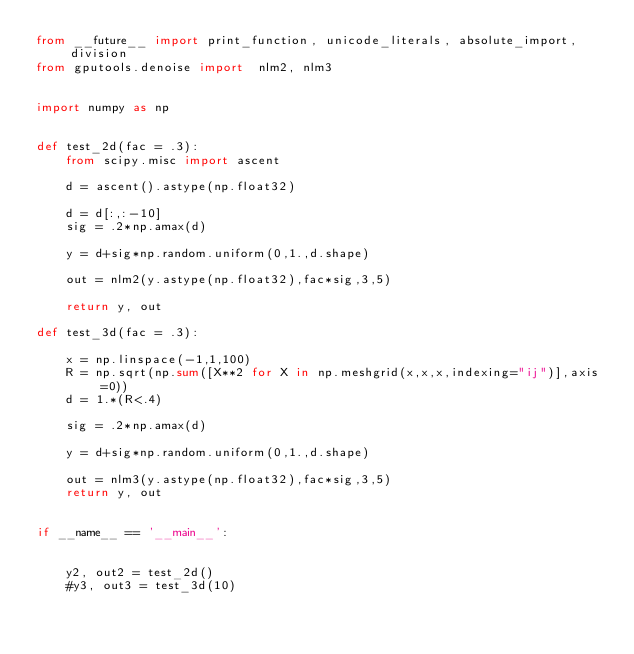<code> <loc_0><loc_0><loc_500><loc_500><_Python_>from __future__ import print_function, unicode_literals, absolute_import, division
from gputools.denoise import  nlm2, nlm3


import numpy as np


def test_2d(fac = .3):
    from scipy.misc import ascent

    d = ascent().astype(np.float32)

    d = d[:,:-10]
    sig = .2*np.amax(d)

    y = d+sig*np.random.uniform(0,1.,d.shape)

    out = nlm2(y.astype(np.float32),fac*sig,3,5)

    return y, out

def test_3d(fac = .3):

    x = np.linspace(-1,1,100)
    R = np.sqrt(np.sum([X**2 for X in np.meshgrid(x,x,x,indexing="ij")],axis=0))
    d = 1.*(R<.4)

    sig = .2*np.amax(d)

    y = d+sig*np.random.uniform(0,1.,d.shape)

    out = nlm3(y.astype(np.float32),fac*sig,3,5)
    return y, out


if __name__ == '__main__':


    y2, out2 = test_2d()
    #y3, out3 = test_3d(10)
</code> 